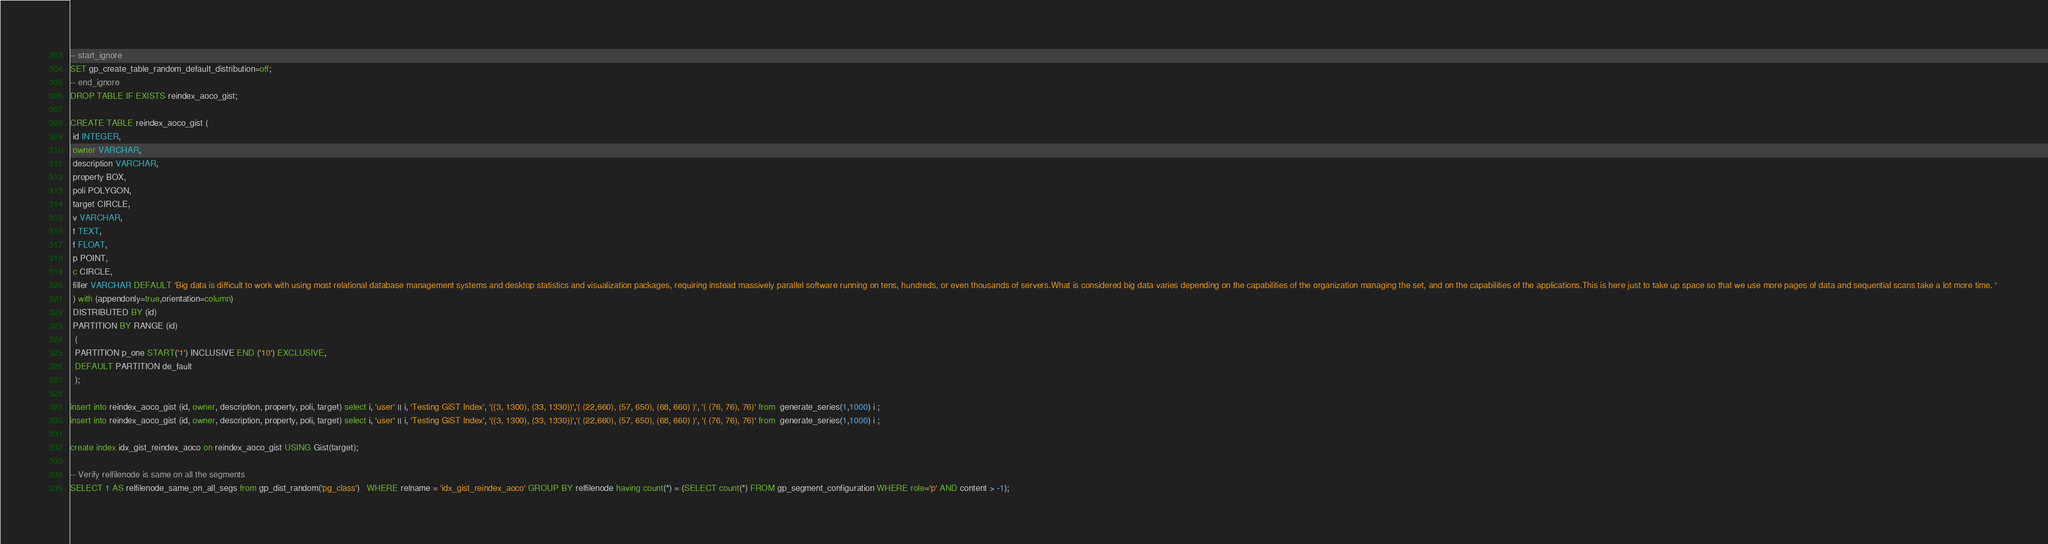<code> <loc_0><loc_0><loc_500><loc_500><_SQL_>-- start_ignore
SET gp_create_table_random_default_distribution=off;
-- end_ignore
DROP TABLE IF EXISTS reindex_aoco_gist;

CREATE TABLE reindex_aoco_gist (
 id INTEGER,
 owner VARCHAR,
 description VARCHAR,
 property BOX, 
 poli POLYGON,
 target CIRCLE,
 v VARCHAR,
 t TEXT,
 f FLOAT, 
 p POINT,
 c CIRCLE,
 filler VARCHAR DEFAULT 'Big data is difficult to work with using most relational database management systems and desktop statistics and visualization packages, requiring instead massively parallel software running on tens, hundreds, or even thousands of servers.What is considered big data varies depending on the capabilities of the organization managing the set, and on the capabilities of the applications.This is here just to take up space so that we use more pages of data and sequential scans take a lot more time. ' 
 ) with (appendonly=true,orientation=column) 
 DISTRIBUTED BY (id)
 PARTITION BY RANGE (id)
  (
  PARTITION p_one START('1') INCLUSIVE END ('10') EXCLUSIVE,
  DEFAULT PARTITION de_fault
  );

insert into reindex_aoco_gist (id, owner, description, property, poli, target) select i, 'user' || i, 'Testing GiST Index', '((3, 1300), (33, 1330))','( (22,660), (57, 650), (68, 660) )', '( (76, 76), 76)' from  generate_series(1,1000) i ;
insert into reindex_aoco_gist (id, owner, description, property, poli, target) select i, 'user' || i, 'Testing GiST Index', '((3, 1300), (33, 1330))','( (22,660), (57, 650), (68, 660) )', '( (76, 76), 76)' from  generate_series(1,1000) i ;

create index idx_gist_reindex_aoco on reindex_aoco_gist USING Gist(target);

-- Verify relfilenode is same on all the segments
SELECT 1 AS relfilenode_same_on_all_segs from gp_dist_random('pg_class')   WHERE relname = 'idx_gist_reindex_aoco' GROUP BY relfilenode having count(*) = (SELECT count(*) FROM gp_segment_configuration WHERE role='p' AND content > -1);
</code> 